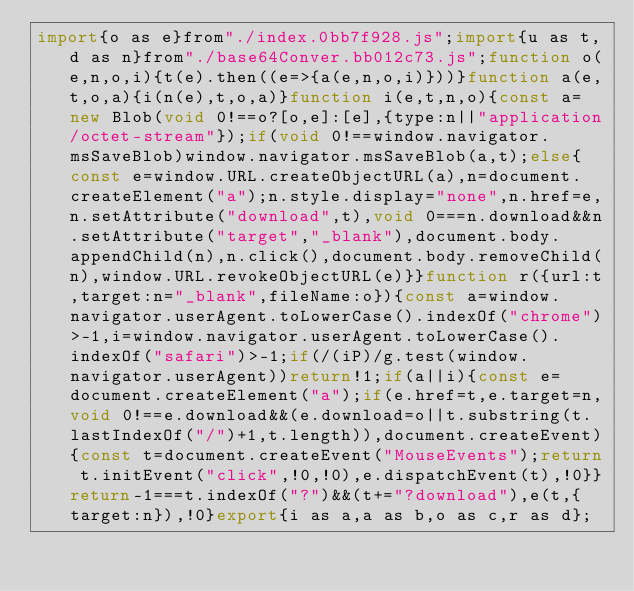<code> <loc_0><loc_0><loc_500><loc_500><_JavaScript_>import{o as e}from"./index.0bb7f928.js";import{u as t,d as n}from"./base64Conver.bb012c73.js";function o(e,n,o,i){t(e).then((e=>{a(e,n,o,i)}))}function a(e,t,o,a){i(n(e),t,o,a)}function i(e,t,n,o){const a=new Blob(void 0!==o?[o,e]:[e],{type:n||"application/octet-stream"});if(void 0!==window.navigator.msSaveBlob)window.navigator.msSaveBlob(a,t);else{const e=window.URL.createObjectURL(a),n=document.createElement("a");n.style.display="none",n.href=e,n.setAttribute("download",t),void 0===n.download&&n.setAttribute("target","_blank"),document.body.appendChild(n),n.click(),document.body.removeChild(n),window.URL.revokeObjectURL(e)}}function r({url:t,target:n="_blank",fileName:o}){const a=window.navigator.userAgent.toLowerCase().indexOf("chrome")>-1,i=window.navigator.userAgent.toLowerCase().indexOf("safari")>-1;if(/(iP)/g.test(window.navigator.userAgent))return!1;if(a||i){const e=document.createElement("a");if(e.href=t,e.target=n,void 0!==e.download&&(e.download=o||t.substring(t.lastIndexOf("/")+1,t.length)),document.createEvent){const t=document.createEvent("MouseEvents");return t.initEvent("click",!0,!0),e.dispatchEvent(t),!0}}return-1===t.indexOf("?")&&(t+="?download"),e(t,{target:n}),!0}export{i as a,a as b,o as c,r as d};
</code> 